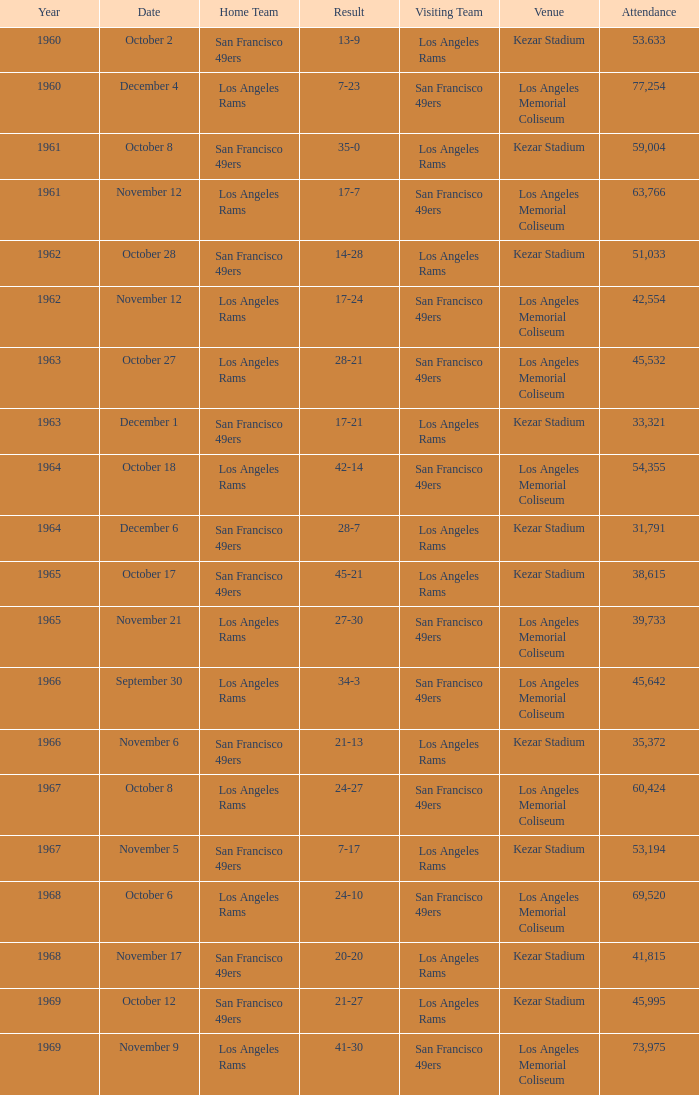When was the earliest year when the attendance was 77,254? 1960.0. 